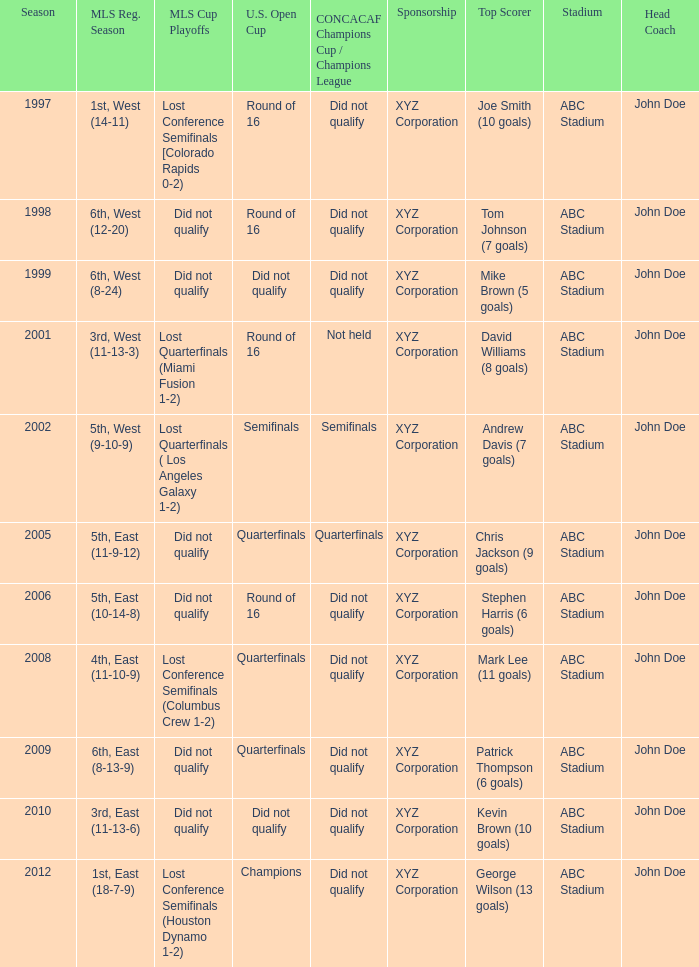What were the placements of the team in regular season when they reached quarterfinals in the U.S. Open Cup but did not qualify for the Concaf Champions Cup? 4th, East (11-10-9), 6th, East (8-13-9). 